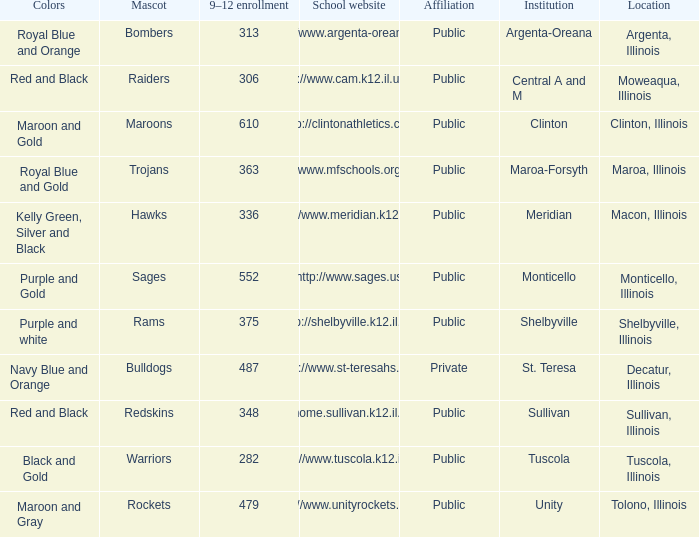How many different combinations of team colors are there in all the schools in Maroa, Illinois? 1.0. 